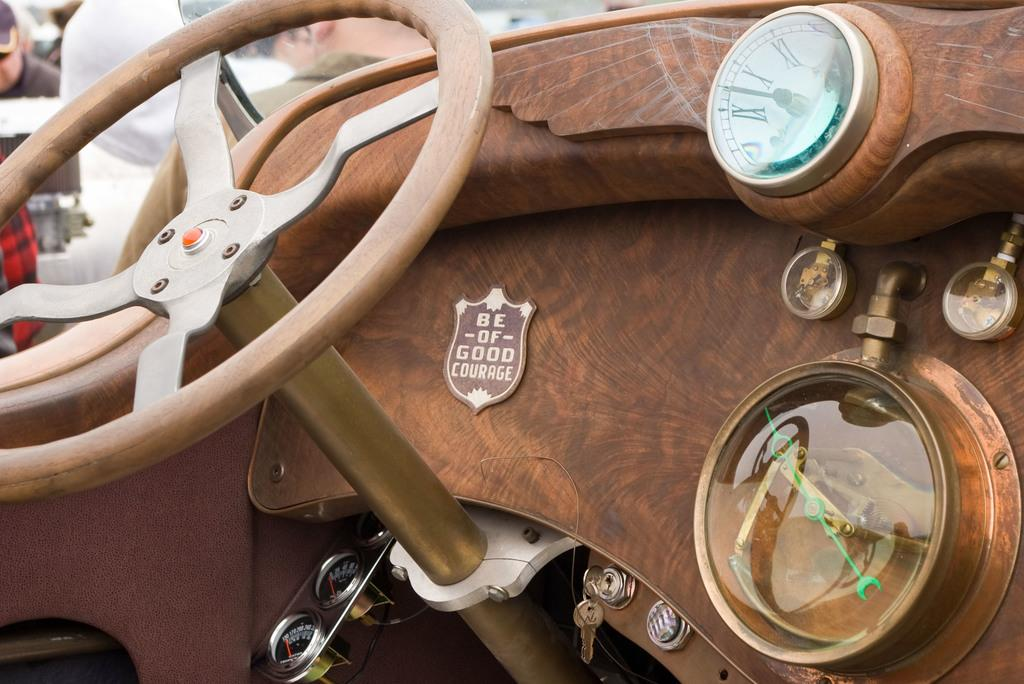What is the main subject of the image? There is a vehicle in the image. Can you describe the people in the background of the image? Unfortunately, the facts provided do not give any details about the people in the background. However, we can confirm that there are people present in the background. What type of orange can be seen hanging from the vehicle in the image? There is no orange present in the image, and it is not hanging from the vehicle. 